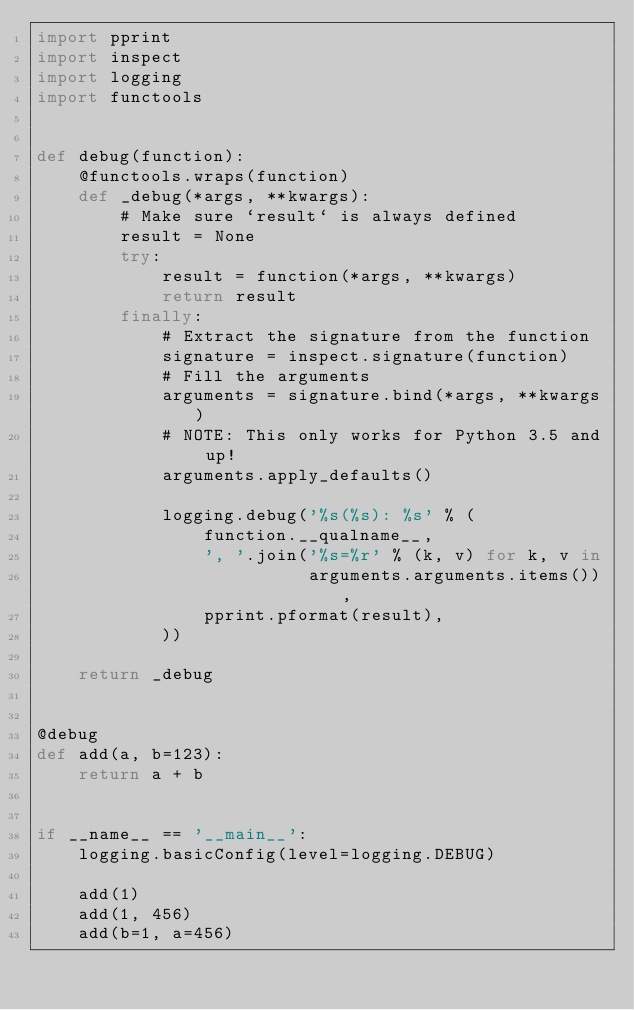<code> <loc_0><loc_0><loc_500><loc_500><_Python_>import pprint
import inspect
import logging
import functools


def debug(function):
    @functools.wraps(function)
    def _debug(*args, **kwargs):
        # Make sure `result` is always defined
        result = None
        try:
            result = function(*args, **kwargs)
            return result
        finally:
            # Extract the signature from the function
            signature = inspect.signature(function)
            # Fill the arguments
            arguments = signature.bind(*args, **kwargs)
            # NOTE: This only works for Python 3.5 and up!
            arguments.apply_defaults()

            logging.debug('%s(%s): %s' % (
                function.__qualname__,
                ', '.join('%s=%r' % (k, v) for k, v in
                          arguments.arguments.items()),
                pprint.pformat(result),
            ))

    return _debug


@debug
def add(a, b=123):
    return a + b


if __name__ == '__main__':
    logging.basicConfig(level=logging.DEBUG)

    add(1)
    add(1, 456)
    add(b=1, a=456)
</code> 